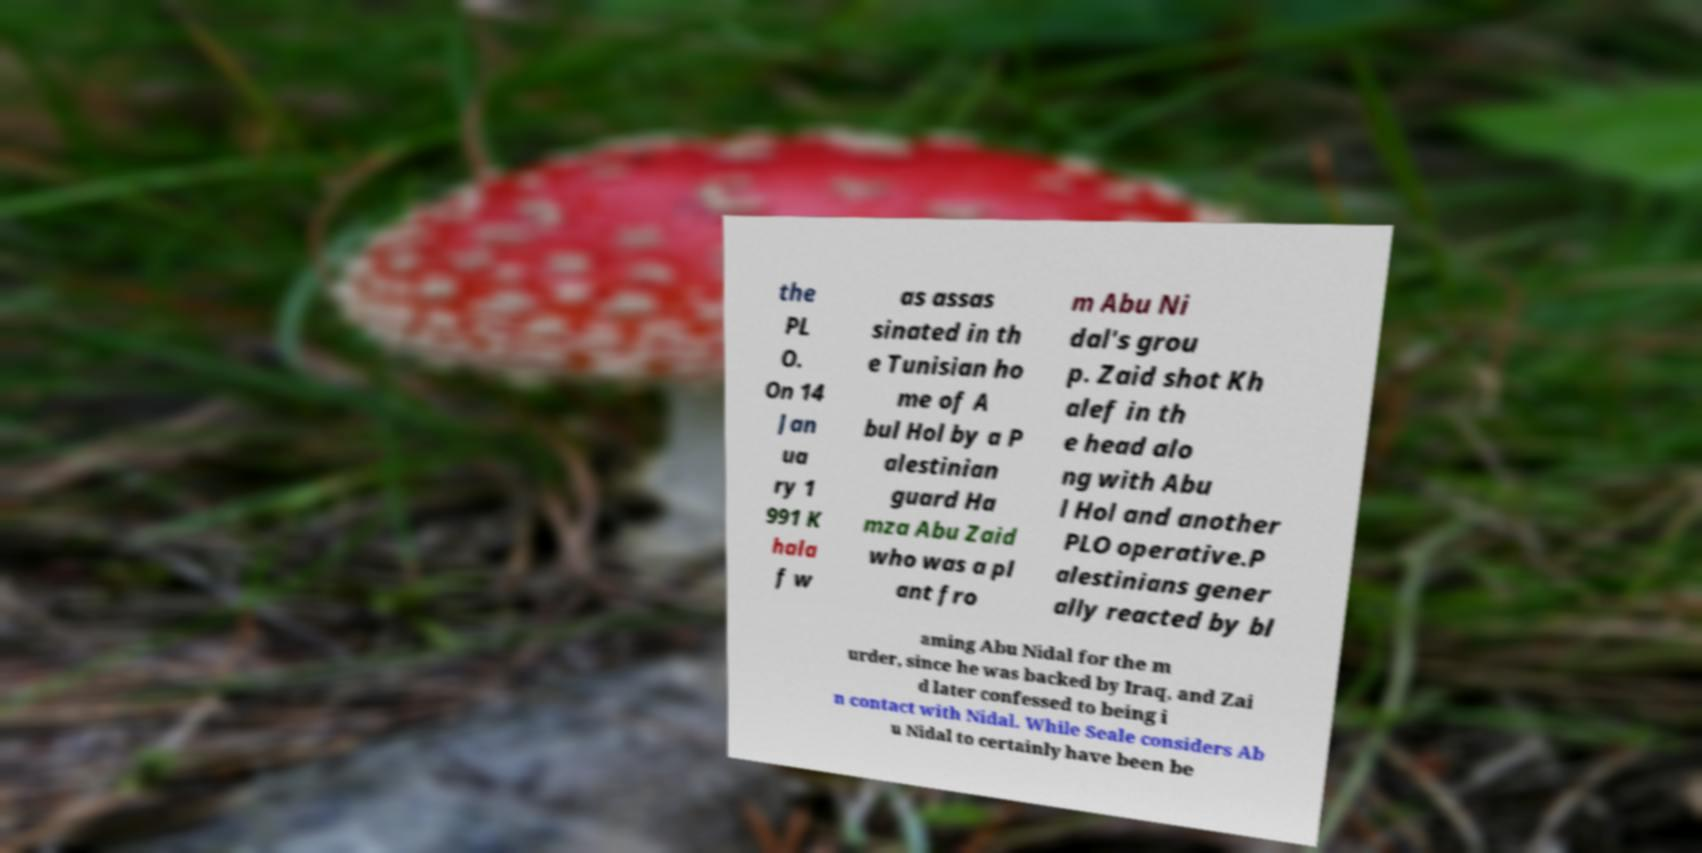Can you accurately transcribe the text from the provided image for me? the PL O. On 14 Jan ua ry 1 991 K hala f w as assas sinated in th e Tunisian ho me of A bul Hol by a P alestinian guard Ha mza Abu Zaid who was a pl ant fro m Abu Ni dal's grou p. Zaid shot Kh alef in th e head alo ng with Abu l Hol and another PLO operative.P alestinians gener ally reacted by bl aming Abu Nidal for the m urder, since he was backed by Iraq, and Zai d later confessed to being i n contact with Nidal. While Seale considers Ab u Nidal to certainly have been be 